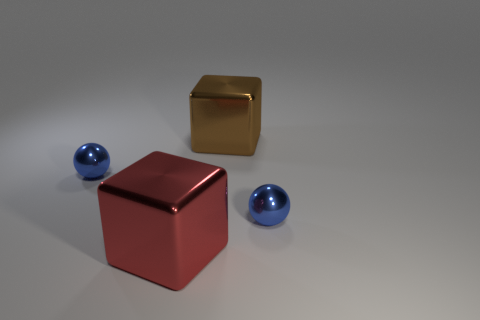There is a blue metallic sphere that is behind the tiny blue shiny sphere to the right of the large brown metal cube; what is its size?
Make the answer very short. Small. There is another large thing that is the same shape as the large red object; what is it made of?
Keep it short and to the point. Metal. Is the color of the small metal sphere that is left of the red metallic object the same as the metallic sphere on the right side of the red cube?
Make the answer very short. Yes. Is there any other thing that is the same shape as the red object?
Keep it short and to the point. Yes. There is a blue shiny sphere that is to the left of the red metallic block; what is its size?
Give a very brief answer. Small. There is a small thing left of the big shiny cube that is right of the red metallic object; what is it made of?
Offer a very short reply. Metal. Is there any other thing that is the same material as the large red block?
Provide a short and direct response. Yes. How many large red objects are the same shape as the brown thing?
Offer a very short reply. 1. What size is the red object that is made of the same material as the large brown object?
Your answer should be very brief. Large. There is a big block that is behind the tiny blue metallic sphere that is to the right of the brown thing; is there a large brown metallic thing behind it?
Provide a succinct answer. No. 